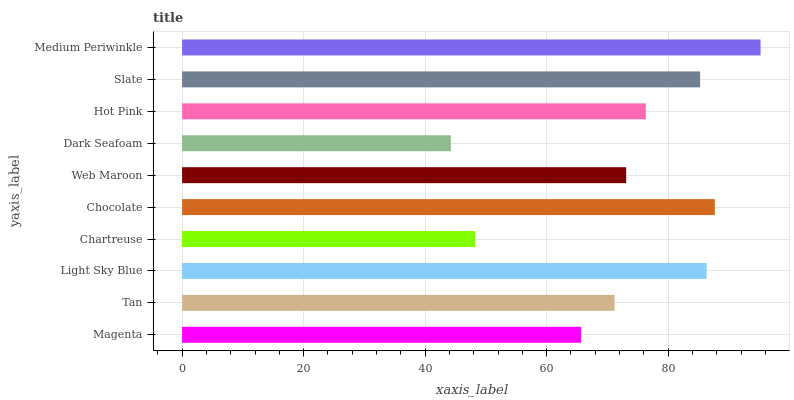Is Dark Seafoam the minimum?
Answer yes or no. Yes. Is Medium Periwinkle the maximum?
Answer yes or no. Yes. Is Tan the minimum?
Answer yes or no. No. Is Tan the maximum?
Answer yes or no. No. Is Tan greater than Magenta?
Answer yes or no. Yes. Is Magenta less than Tan?
Answer yes or no. Yes. Is Magenta greater than Tan?
Answer yes or no. No. Is Tan less than Magenta?
Answer yes or no. No. Is Hot Pink the high median?
Answer yes or no. Yes. Is Web Maroon the low median?
Answer yes or no. Yes. Is Web Maroon the high median?
Answer yes or no. No. Is Medium Periwinkle the low median?
Answer yes or no. No. 